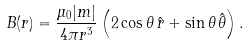Convert formula to latex. <formula><loc_0><loc_0><loc_500><loc_500>B ( { r } ) = { \frac { \mu _ { 0 } | m | } { 4 \pi r ^ { 3 } } } \left ( 2 \cos \theta \, \hat { r } + \sin \theta \, { \hat { \theta } } \right ) .</formula> 